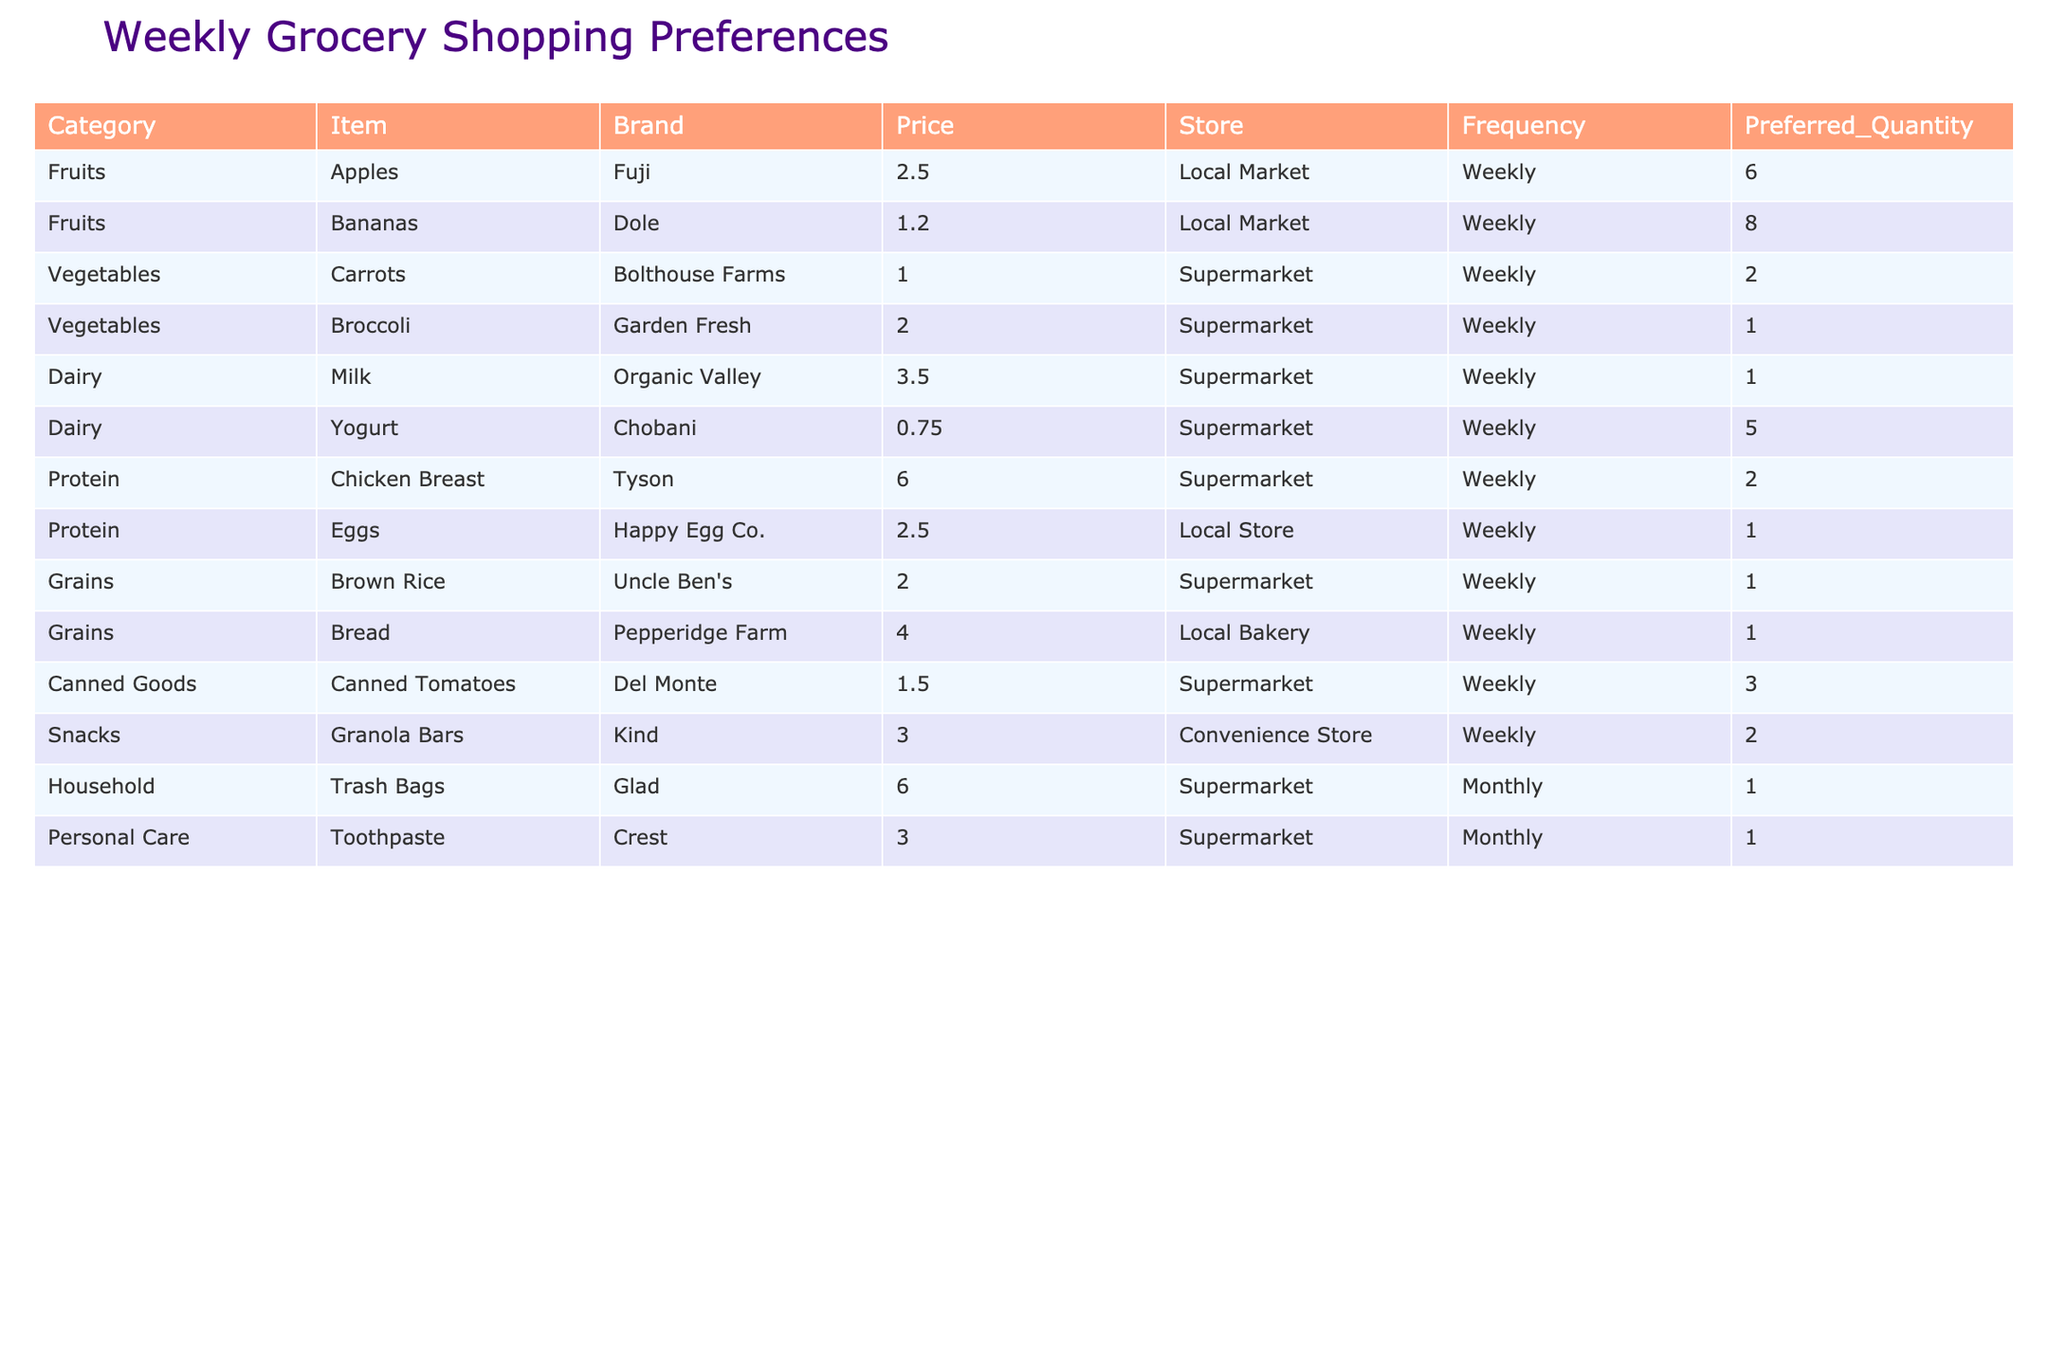What is the price of organic milk? The table under the Dairy category shows that the price listed for Organic Valley milk is 3.50.
Answer: 3.50 How many bananas does the single mother prefer to buy? From the Fruits category, the Preferred Quantity for Dole bananas is listed as 8.
Answer: 8 What is the total cost for the preferred quantity of apples? The price for Fuji apples is 2.50, and the preferred quantity is 6. We calculate the total cost by multiplying the price by the quantity: 2.50 * 6 = 15.00.
Answer: 15.00 Is the chicken breast from Tyson the most expensive protein listed? In the Protein category, we compare the prices: Tyson chicken breast costs 6.00, and Happy Egg Co. eggs cost 2.50. Since 6.00 is greater than 2.50, Tyson chicken breast is indeed the most expensive protein option.
Answer: Yes What is the total weekly budget needed for all the preferred grocery items listed? We first find the total cost by calculating the costs for each item: (2.50 * 6) + (1.20 * 8) + (1.00 * 2) + (2.00 * 1) + (3.50 * 1) + (0.75 * 5) + (6.00 * 2) + (2.50 * 1) + (2.00 * 1) + (4.00 * 1) + (1.50 * 3) + (3.00 * 2) = 15.00 + 9.60 + 2.00 + 2.00 + 3.50 + 3.75 + 12.00 + 2.50 + 2.00 + 4.00 + 4.50 + 6.00 =  63.35.
Answer: 63.35 What percentage of the total weekly grocery budget is spent on fruits? From the total weekly budget of 63.35, we find the total cost for fruits: (2.50 * 6) + (1.20 * 8) = 15.00 + 9.60 = 24.60. Then, to calculate the percentage, we take (24.60 / 63.35) * 100 which is approximately 38.8%.
Answer: 38.8% 